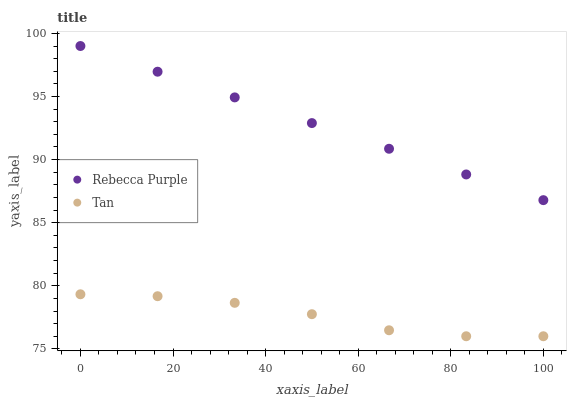Does Tan have the minimum area under the curve?
Answer yes or no. Yes. Does Rebecca Purple have the maximum area under the curve?
Answer yes or no. Yes. Does Rebecca Purple have the minimum area under the curve?
Answer yes or no. No. Is Rebecca Purple the smoothest?
Answer yes or no. Yes. Is Tan the roughest?
Answer yes or no. Yes. Is Rebecca Purple the roughest?
Answer yes or no. No. Does Tan have the lowest value?
Answer yes or no. Yes. Does Rebecca Purple have the lowest value?
Answer yes or no. No. Does Rebecca Purple have the highest value?
Answer yes or no. Yes. Is Tan less than Rebecca Purple?
Answer yes or no. Yes. Is Rebecca Purple greater than Tan?
Answer yes or no. Yes. Does Tan intersect Rebecca Purple?
Answer yes or no. No. 